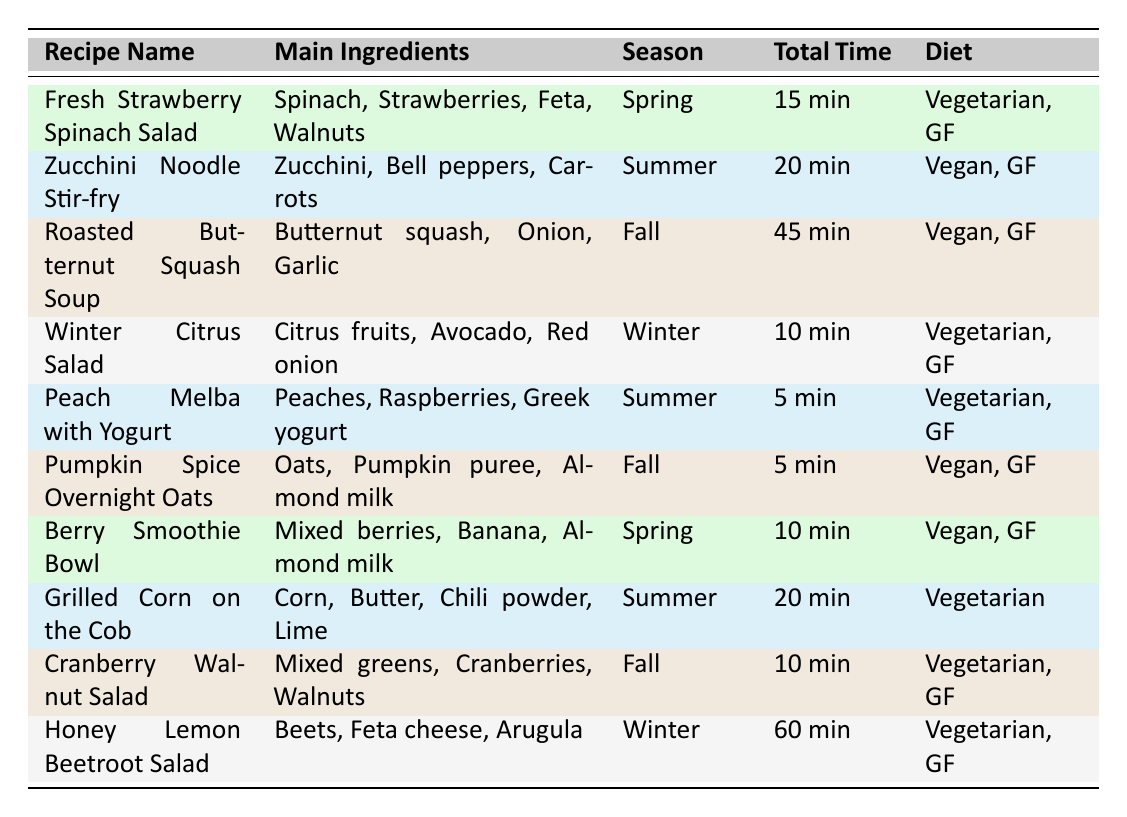What is the total cooking time for the Roasted Butternut Squash Soup? The cooking time for the Roasted Butternut Squash Soup is listed as 30 minutes. Therefore, the total cooking time is simply that value.
Answer: 30 minutes How many servings does the Winter Citrus Salad provide? The Winter Citrus Salad is indicated to serve 4 people according to the table.
Answer: 4 What recipes are suitable for a vegan diet? By checking the dietary preferences column, the recipes that are labeled as "Vegan" are the Zucchini Noodle Stir-fry, Roasted Butternut Squash Soup, Pumpkin Spice Overnight Oats, and Berry Smoothie Bowl. These are the recipes that are suitable for a vegan diet.
Answer: Zucchini Noodle Stir-fry, Roasted Butternut Squash Soup, Pumpkin Spice Overnight Oats, Berry Smoothie Bowl Which recipe has the shortest preparation time? The recipe with the shortest preparation time is the Peach Melba with Yogurt, which only takes 5 minutes to prepare. This is found by comparing the prep time across all recipes in the table.
Answer: Peach Melba with Yogurt How many vegetarian recipes are listed in the table? By examining the table, we find that there are a total of 6 vegetarian recipes: Fresh Strawberry Spinach Salad, Winter Citrus Salad, Peach Melba with Yogurt, Grilled Corn on the Cob, Cranberry Walnut Salad, and Honey Lemon Beetroot Salad. Thus, adding these gives us the total count of vegetarian recipes.
Answer: 6 Is the Berry Smoothie Bowl a gluten-free recipe? In the dietary preferences for the Berry Smoothie Bowl, it is marked as "Gluten-free." Therefore, the answer to whether it is gluten-free is yes.
Answer: Yes What is the average prep time for the recipes available in the summer? To find this, we first identify the recipes in the summer, which are the Zucchini Noodle Stir-fry, Peach Melba with Yogurt, and Grilled Corn on the Cob. Their prep times are 10 minutes, 5 minutes, and 5 minutes, respectively. Next, we sum these prep times (10 + 5 + 5 = 20) and then divide by the number of recipes (20 / 3 = 6.67). This gives us the average prep time for summer recipes.
Answer: 6.67 minutes How many recipes call for butternut squash? By reviewing the table, it is clear that only one recipe, the Roasted Butternut Squash Soup, specifically lists butternut squash as an ingredient. So the total count is one.
Answer: 1 Which recipes from the table are gluten-free? To ascertain the gluten-free options, we check each recipe's dietary preferences. The recipes that are labeled as gluten-free are Fresh Strawberry Spinach Salad, Zucchini Noodle Stir-fry, Roasted Butternut Squash Soup, Winter Citrus Salad, Peach Melba with Yogurt, Pumpkin Spice Overnight Oats, Berry Smoothie Bowl, Cranberry Walnut Salad, and Honey Lemon Beetroot Salad, amounting to a total of 9 recipes.
Answer: 9 